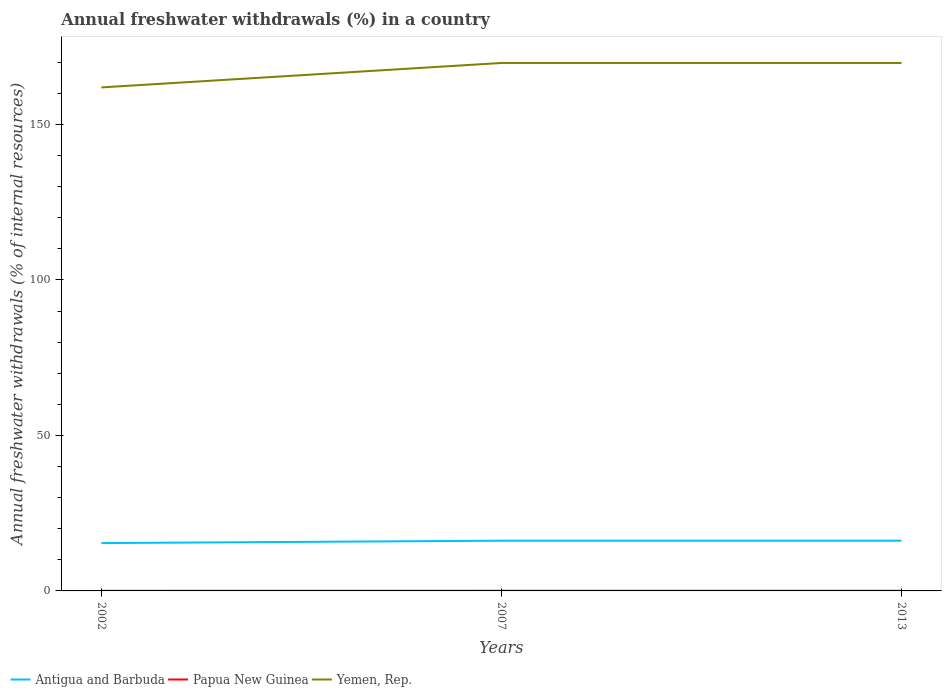Across all years, what is the maximum percentage of annual freshwater withdrawals in Papua New Guinea?
Ensure brevity in your answer.  0.03. What is the total percentage of annual freshwater withdrawals in Papua New Guinea in the graph?
Offer a very short reply. 0. What is the difference between the highest and the second highest percentage of annual freshwater withdrawals in Yemen, Rep.?
Your answer should be compact. 7.86. How many lines are there?
Your answer should be very brief. 3. How many years are there in the graph?
Your answer should be very brief. 3. Does the graph contain any zero values?
Your answer should be compact. No. How are the legend labels stacked?
Give a very brief answer. Horizontal. What is the title of the graph?
Provide a short and direct response. Annual freshwater withdrawals (%) in a country. What is the label or title of the Y-axis?
Offer a very short reply. Annual freshwater withdrawals (% of internal resources). What is the Annual freshwater withdrawals (% of internal resources) of Antigua and Barbuda in 2002?
Your answer should be compact. 15.38. What is the Annual freshwater withdrawals (% of internal resources) of Papua New Guinea in 2002?
Provide a succinct answer. 0.03. What is the Annual freshwater withdrawals (% of internal resources) in Yemen, Rep. in 2002?
Ensure brevity in your answer.  161.9. What is the Annual freshwater withdrawals (% of internal resources) of Antigua and Barbuda in 2007?
Provide a succinct answer. 16.15. What is the Annual freshwater withdrawals (% of internal resources) of Papua New Guinea in 2007?
Keep it short and to the point. 0.05. What is the Annual freshwater withdrawals (% of internal resources) in Yemen, Rep. in 2007?
Offer a terse response. 169.76. What is the Annual freshwater withdrawals (% of internal resources) in Antigua and Barbuda in 2013?
Your answer should be compact. 16.15. What is the Annual freshwater withdrawals (% of internal resources) in Papua New Guinea in 2013?
Your answer should be very brief. 0.05. What is the Annual freshwater withdrawals (% of internal resources) in Yemen, Rep. in 2013?
Your answer should be compact. 169.76. Across all years, what is the maximum Annual freshwater withdrawals (% of internal resources) of Antigua and Barbuda?
Offer a terse response. 16.15. Across all years, what is the maximum Annual freshwater withdrawals (% of internal resources) in Papua New Guinea?
Provide a succinct answer. 0.05. Across all years, what is the maximum Annual freshwater withdrawals (% of internal resources) of Yemen, Rep.?
Provide a short and direct response. 169.76. Across all years, what is the minimum Annual freshwater withdrawals (% of internal resources) of Antigua and Barbuda?
Your response must be concise. 15.38. Across all years, what is the minimum Annual freshwater withdrawals (% of internal resources) in Papua New Guinea?
Offer a terse response. 0.03. Across all years, what is the minimum Annual freshwater withdrawals (% of internal resources) of Yemen, Rep.?
Provide a succinct answer. 161.9. What is the total Annual freshwater withdrawals (% of internal resources) in Antigua and Barbuda in the graph?
Your answer should be compact. 47.69. What is the total Annual freshwater withdrawals (% of internal resources) in Papua New Guinea in the graph?
Offer a very short reply. 0.13. What is the total Annual freshwater withdrawals (% of internal resources) in Yemen, Rep. in the graph?
Your answer should be compact. 501.43. What is the difference between the Annual freshwater withdrawals (% of internal resources) in Antigua and Barbuda in 2002 and that in 2007?
Ensure brevity in your answer.  -0.77. What is the difference between the Annual freshwater withdrawals (% of internal resources) of Papua New Guinea in 2002 and that in 2007?
Keep it short and to the point. -0.02. What is the difference between the Annual freshwater withdrawals (% of internal resources) of Yemen, Rep. in 2002 and that in 2007?
Your answer should be very brief. -7.86. What is the difference between the Annual freshwater withdrawals (% of internal resources) of Antigua and Barbuda in 2002 and that in 2013?
Your answer should be compact. -0.77. What is the difference between the Annual freshwater withdrawals (% of internal resources) of Papua New Guinea in 2002 and that in 2013?
Your answer should be very brief. -0.02. What is the difference between the Annual freshwater withdrawals (% of internal resources) of Yemen, Rep. in 2002 and that in 2013?
Keep it short and to the point. -7.86. What is the difference between the Annual freshwater withdrawals (% of internal resources) in Papua New Guinea in 2007 and that in 2013?
Make the answer very short. 0. What is the difference between the Annual freshwater withdrawals (% of internal resources) in Antigua and Barbuda in 2002 and the Annual freshwater withdrawals (% of internal resources) in Papua New Guinea in 2007?
Your response must be concise. 15.34. What is the difference between the Annual freshwater withdrawals (% of internal resources) in Antigua and Barbuda in 2002 and the Annual freshwater withdrawals (% of internal resources) in Yemen, Rep. in 2007?
Your response must be concise. -154.38. What is the difference between the Annual freshwater withdrawals (% of internal resources) in Papua New Guinea in 2002 and the Annual freshwater withdrawals (% of internal resources) in Yemen, Rep. in 2007?
Make the answer very short. -169.73. What is the difference between the Annual freshwater withdrawals (% of internal resources) of Antigua and Barbuda in 2002 and the Annual freshwater withdrawals (% of internal resources) of Papua New Guinea in 2013?
Make the answer very short. 15.34. What is the difference between the Annual freshwater withdrawals (% of internal resources) of Antigua and Barbuda in 2002 and the Annual freshwater withdrawals (% of internal resources) of Yemen, Rep. in 2013?
Provide a short and direct response. -154.38. What is the difference between the Annual freshwater withdrawals (% of internal resources) of Papua New Guinea in 2002 and the Annual freshwater withdrawals (% of internal resources) of Yemen, Rep. in 2013?
Ensure brevity in your answer.  -169.73. What is the difference between the Annual freshwater withdrawals (% of internal resources) in Antigua and Barbuda in 2007 and the Annual freshwater withdrawals (% of internal resources) in Papua New Guinea in 2013?
Provide a short and direct response. 16.1. What is the difference between the Annual freshwater withdrawals (% of internal resources) in Antigua and Barbuda in 2007 and the Annual freshwater withdrawals (% of internal resources) in Yemen, Rep. in 2013?
Offer a terse response. -153.61. What is the difference between the Annual freshwater withdrawals (% of internal resources) of Papua New Guinea in 2007 and the Annual freshwater withdrawals (% of internal resources) of Yemen, Rep. in 2013?
Your answer should be compact. -169.71. What is the average Annual freshwater withdrawals (% of internal resources) of Antigua and Barbuda per year?
Offer a terse response. 15.9. What is the average Annual freshwater withdrawals (% of internal resources) of Papua New Guinea per year?
Ensure brevity in your answer.  0.04. What is the average Annual freshwater withdrawals (% of internal resources) of Yemen, Rep. per year?
Give a very brief answer. 167.14. In the year 2002, what is the difference between the Annual freshwater withdrawals (% of internal resources) in Antigua and Barbuda and Annual freshwater withdrawals (% of internal resources) in Papua New Guinea?
Provide a short and direct response. 15.35. In the year 2002, what is the difference between the Annual freshwater withdrawals (% of internal resources) of Antigua and Barbuda and Annual freshwater withdrawals (% of internal resources) of Yemen, Rep.?
Offer a terse response. -146.52. In the year 2002, what is the difference between the Annual freshwater withdrawals (% of internal resources) in Papua New Guinea and Annual freshwater withdrawals (% of internal resources) in Yemen, Rep.?
Ensure brevity in your answer.  -161.87. In the year 2007, what is the difference between the Annual freshwater withdrawals (% of internal resources) in Antigua and Barbuda and Annual freshwater withdrawals (% of internal resources) in Papua New Guinea?
Offer a terse response. 16.1. In the year 2007, what is the difference between the Annual freshwater withdrawals (% of internal resources) in Antigua and Barbuda and Annual freshwater withdrawals (% of internal resources) in Yemen, Rep.?
Your answer should be compact. -153.61. In the year 2007, what is the difference between the Annual freshwater withdrawals (% of internal resources) in Papua New Guinea and Annual freshwater withdrawals (% of internal resources) in Yemen, Rep.?
Offer a terse response. -169.71. In the year 2013, what is the difference between the Annual freshwater withdrawals (% of internal resources) in Antigua and Barbuda and Annual freshwater withdrawals (% of internal resources) in Papua New Guinea?
Ensure brevity in your answer.  16.1. In the year 2013, what is the difference between the Annual freshwater withdrawals (% of internal resources) in Antigua and Barbuda and Annual freshwater withdrawals (% of internal resources) in Yemen, Rep.?
Your response must be concise. -153.61. In the year 2013, what is the difference between the Annual freshwater withdrawals (% of internal resources) of Papua New Guinea and Annual freshwater withdrawals (% of internal resources) of Yemen, Rep.?
Offer a very short reply. -169.71. What is the ratio of the Annual freshwater withdrawals (% of internal resources) of Papua New Guinea in 2002 to that in 2007?
Keep it short and to the point. 0.69. What is the ratio of the Annual freshwater withdrawals (% of internal resources) in Yemen, Rep. in 2002 to that in 2007?
Your response must be concise. 0.95. What is the ratio of the Annual freshwater withdrawals (% of internal resources) of Antigua and Barbuda in 2002 to that in 2013?
Ensure brevity in your answer.  0.95. What is the ratio of the Annual freshwater withdrawals (% of internal resources) of Papua New Guinea in 2002 to that in 2013?
Your response must be concise. 0.69. What is the ratio of the Annual freshwater withdrawals (% of internal resources) of Yemen, Rep. in 2002 to that in 2013?
Offer a very short reply. 0.95. What is the ratio of the Annual freshwater withdrawals (% of internal resources) in Papua New Guinea in 2007 to that in 2013?
Your response must be concise. 1. What is the difference between the highest and the second highest Annual freshwater withdrawals (% of internal resources) of Antigua and Barbuda?
Your answer should be very brief. 0. What is the difference between the highest and the lowest Annual freshwater withdrawals (% of internal resources) in Antigua and Barbuda?
Keep it short and to the point. 0.77. What is the difference between the highest and the lowest Annual freshwater withdrawals (% of internal resources) of Papua New Guinea?
Offer a terse response. 0.02. What is the difference between the highest and the lowest Annual freshwater withdrawals (% of internal resources) in Yemen, Rep.?
Your answer should be compact. 7.86. 